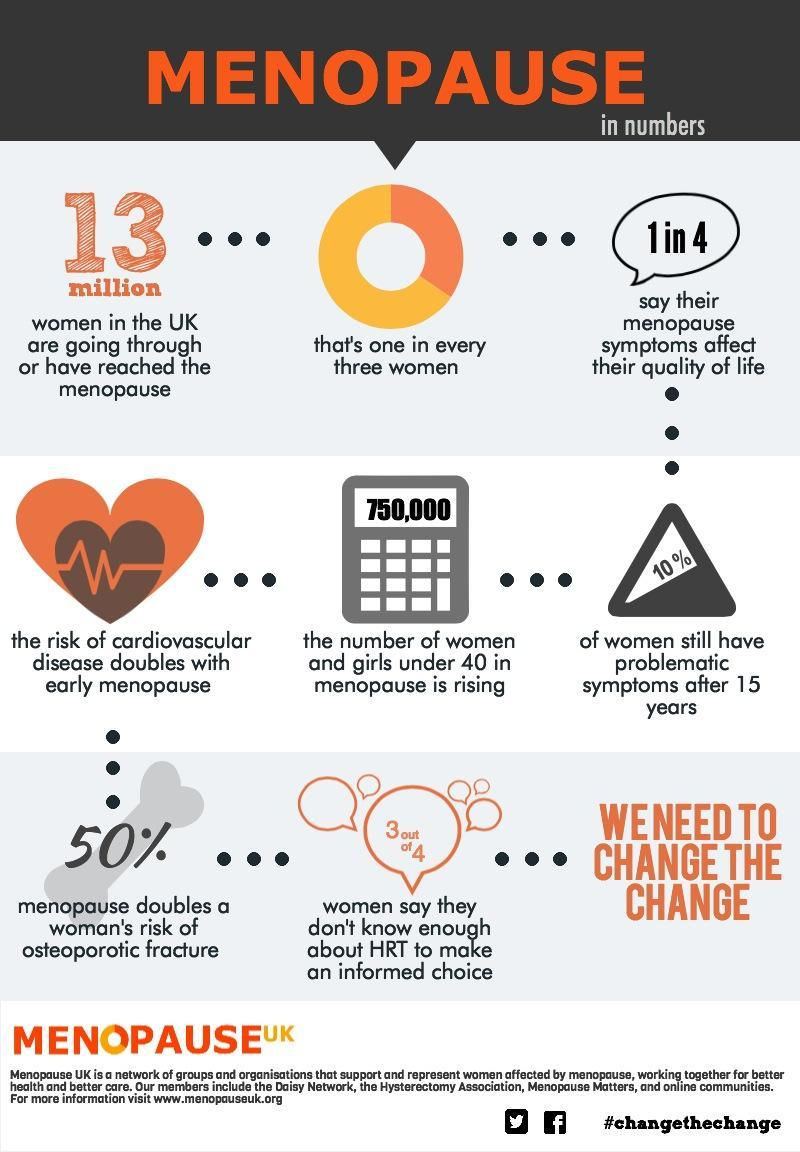What percentage of women in UK do not have any problematic symptoms after menopause?
Answer the question with a short phrase. 90% What percentage the menopause can double a women's risk of osteoporotic fracture? 50% What population of women in UK are going through or have reached the menopause? 13 million 